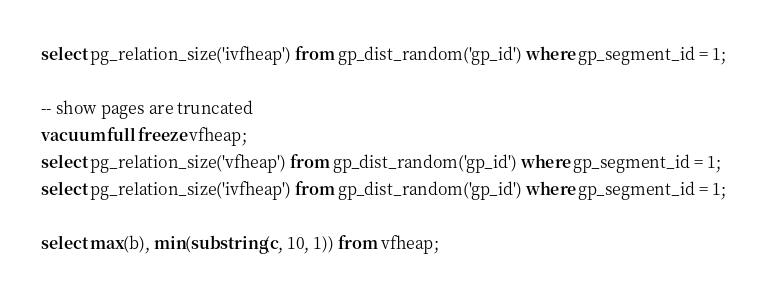Convert code to text. <code><loc_0><loc_0><loc_500><loc_500><_SQL_>select pg_relation_size('ivfheap') from gp_dist_random('gp_id') where gp_segment_id = 1;

-- show pages are truncated
vacuum full freeze vfheap;
select pg_relation_size('vfheap') from gp_dist_random('gp_id') where gp_segment_id = 1;
select pg_relation_size('ivfheap') from gp_dist_random('gp_id') where gp_segment_id = 1;

select max(b), min(substring(c, 10, 1)) from vfheap;
</code> 